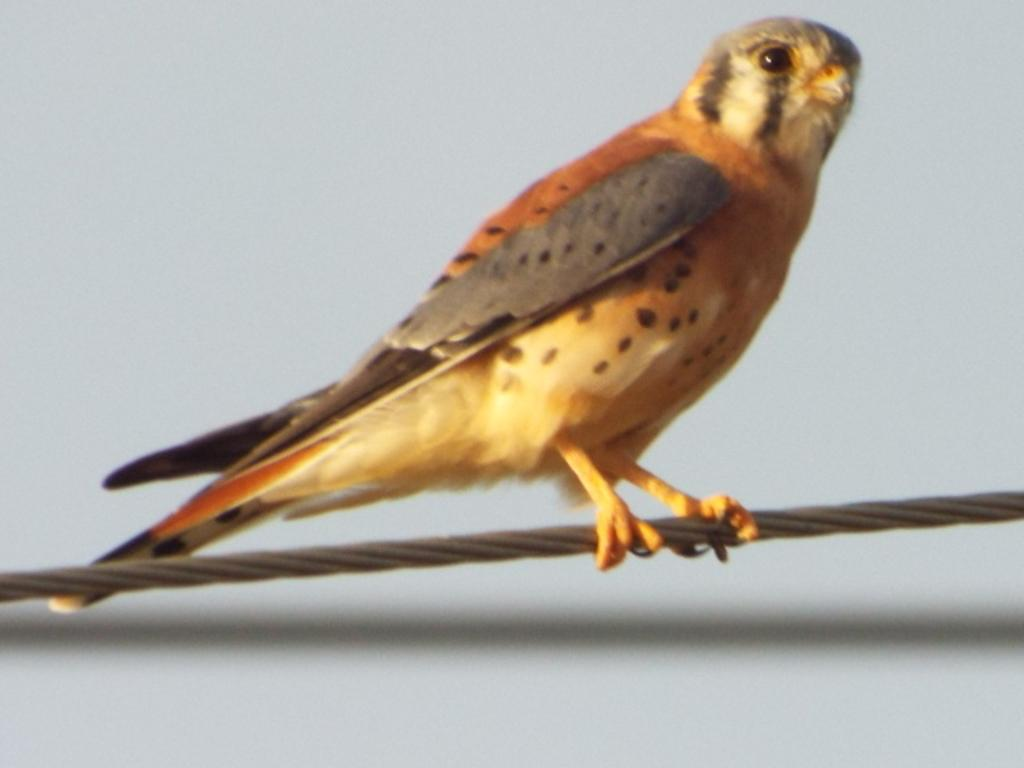What type of animal can be seen in the image? There is a bird in the image. Can you describe the bird's coloring? The bird is ash, black, orange, and white in color. Where is the bird located in the image? The bird is standing on a wire. What is the color of the background in the image? The background of the image is white. What level of experience does the bird have in flying? The bird's experience level in flying cannot be determined from the image. In which direction is the bird facing in the image? The bird's direction in the image cannot be determined from the image. 